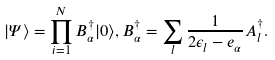Convert formula to latex. <formula><loc_0><loc_0><loc_500><loc_500>| \Psi \rangle = \prod _ { i = 1 } ^ { N } B ^ { \dagger } _ { \alpha } | 0 \rangle , B ^ { \dagger } _ { \alpha } = \sum _ { l } \frac { 1 } { 2 \epsilon _ { l } - e _ { \alpha } } A ^ { \dagger } _ { l } .</formula> 